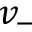Convert formula to latex. <formula><loc_0><loc_0><loc_500><loc_500>v _ { - }</formula> 